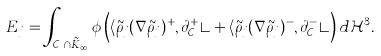Convert formula to latex. <formula><loc_0><loc_0><loc_500><loc_500>E _ { j } = \int _ { \mathcal { C } _ { j } \cap \tilde { K } _ { \infty } } \phi \left ( \langle \tilde { \rho } _ { j } ( \nabla \tilde { \rho } _ { j } ) ^ { + } , \partial _ { \mathcal { C } _ { j } } ^ { + } \rangle + \langle \tilde { \rho } _ { j } ( \nabla \tilde { \rho } _ { j } ) ^ { - } , \partial _ { \mathcal { C } _ { j } } ^ { - } \rangle \right ) d \mathcal { H } ^ { 3 } .</formula> 